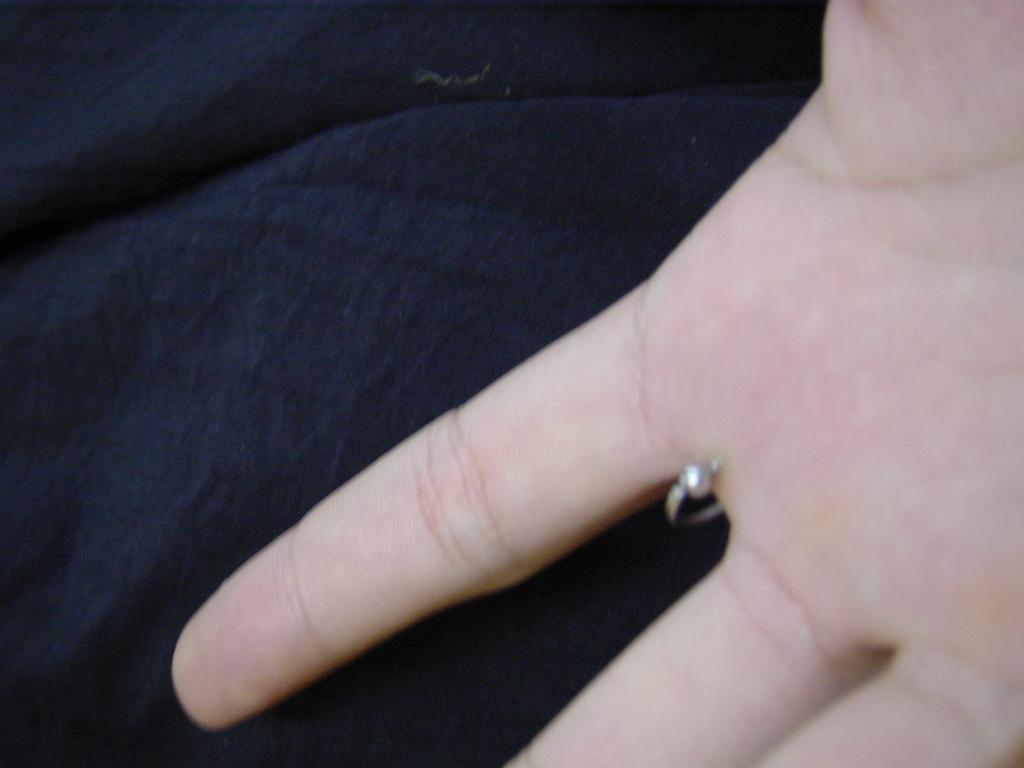What part of a person's body is visible in the image? There is a person's hand in the image. What is located at the bottom of the image? There is a cloth at the bottom of the image. What type of engine is visible in the image? There is no engine present in the image. Can you point out the door in the image? There is no door present in the image. 